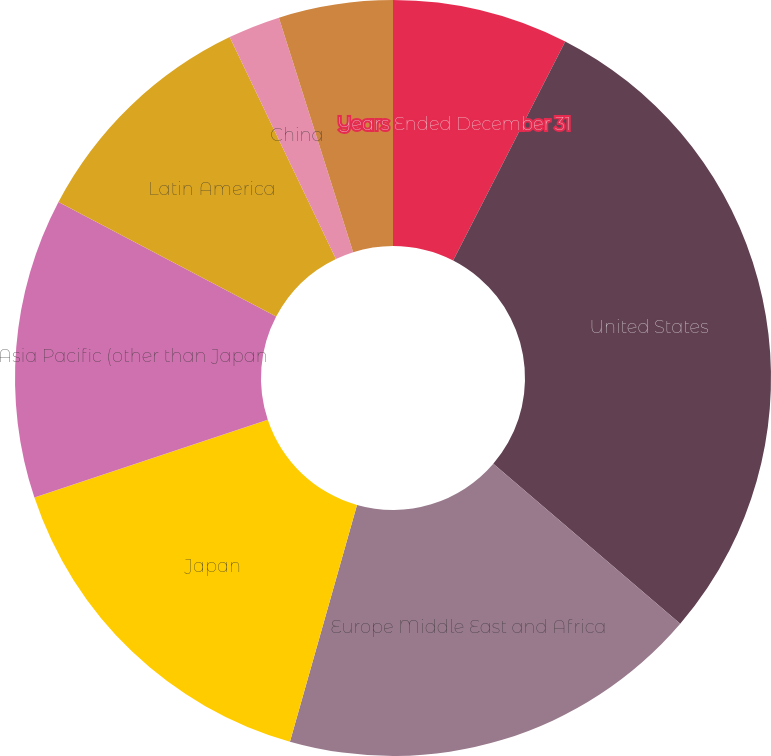<chart> <loc_0><loc_0><loc_500><loc_500><pie_chart><fcel>Years Ended December 31<fcel>United States<fcel>Europe Middle East and Africa<fcel>Japan<fcel>Asia Pacific (other than Japan<fcel>Latin America<fcel>China<fcel>Other<nl><fcel>7.53%<fcel>28.73%<fcel>18.13%<fcel>15.48%<fcel>12.83%<fcel>10.18%<fcel>2.23%<fcel>4.88%<nl></chart> 